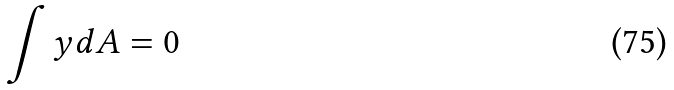<formula> <loc_0><loc_0><loc_500><loc_500>\int y d A = 0</formula> 